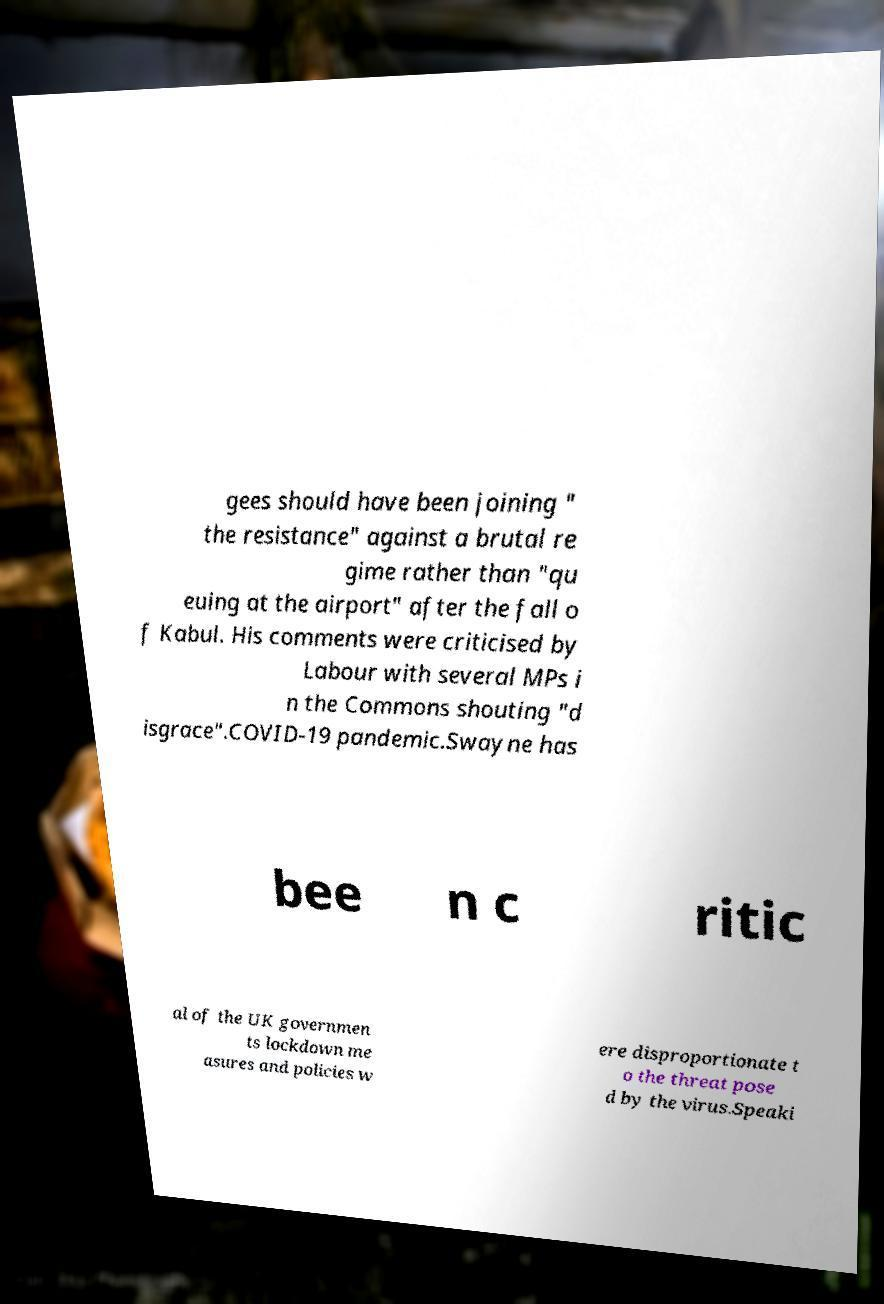Please read and relay the text visible in this image. What does it say? gees should have been joining " the resistance" against a brutal re gime rather than "qu euing at the airport" after the fall o f Kabul. His comments were criticised by Labour with several MPs i n the Commons shouting "d isgrace".COVID-19 pandemic.Swayne has bee n c ritic al of the UK governmen ts lockdown me asures and policies w ere disproportionate t o the threat pose d by the virus.Speaki 